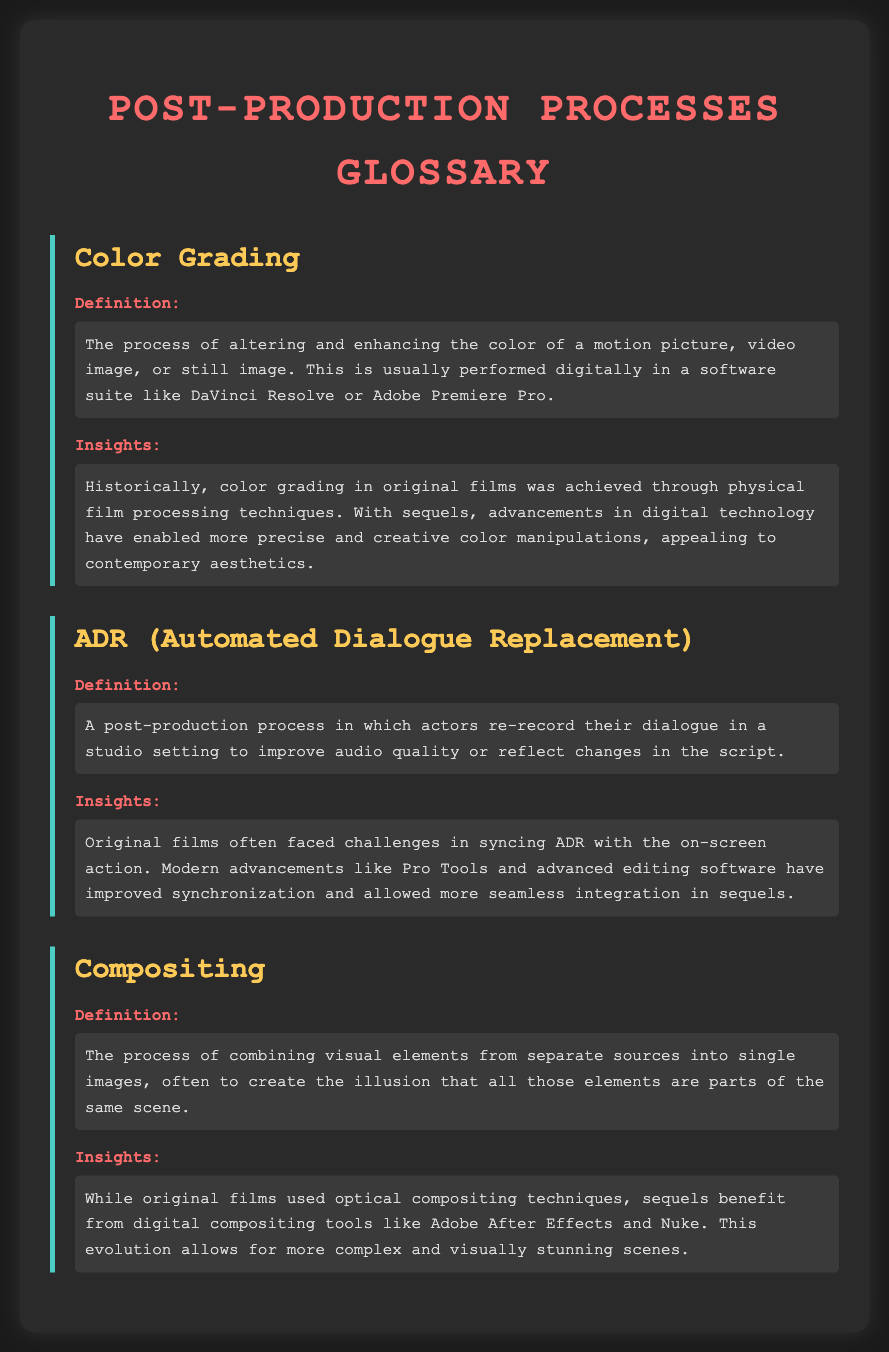What is color grading? Color grading is defined as the process of altering and enhancing the color of a motion picture, video image, or still image.
Answer: The process of altering and enhancing the color of a motion picture, video image, or still image What software is commonly used for color grading? The document mentions specific software used for color grading, such as DaVinci Resolve or Adobe Premiere Pro.
Answer: DaVinci Resolve or Adobe Premiere Pro What does ADR stand for? The term ADR is defined in the document as Automated Dialogue Replacement.
Answer: Automated Dialogue Replacement What is the primary benefit of modern ADR techniques? The document states that modern advancements improve synchronization and integration of ADR.
Answer: Improved synchronization and integration What was the technique used for compositing in original films? The definition of compositing indicates that original films used optical compositing techniques.
Answer: Optical compositing techniques Which digital tools are mentioned for compositing? The insights section refers to digital tools like Adobe After Effects and Nuke for modern compositing.
Answer: Adobe After Effects and Nuke What is one way color grading has evolved from original films to sequels? The document explains that advancements in digital technology have enabled more precise and creative color manipulations in sequels.
Answer: More precise and creative color manipulations How has ADR technology improved from original films to sequels? According to the insights, modern advancements like Pro Tools have improved synchronization in sequels.
Answer: Improved synchronization What type of post-production process involves actors re-recording dialogue? The definition section describes this process as ADR or Automated Dialogue Replacement.
Answer: ADR or Automated Dialogue Replacement 